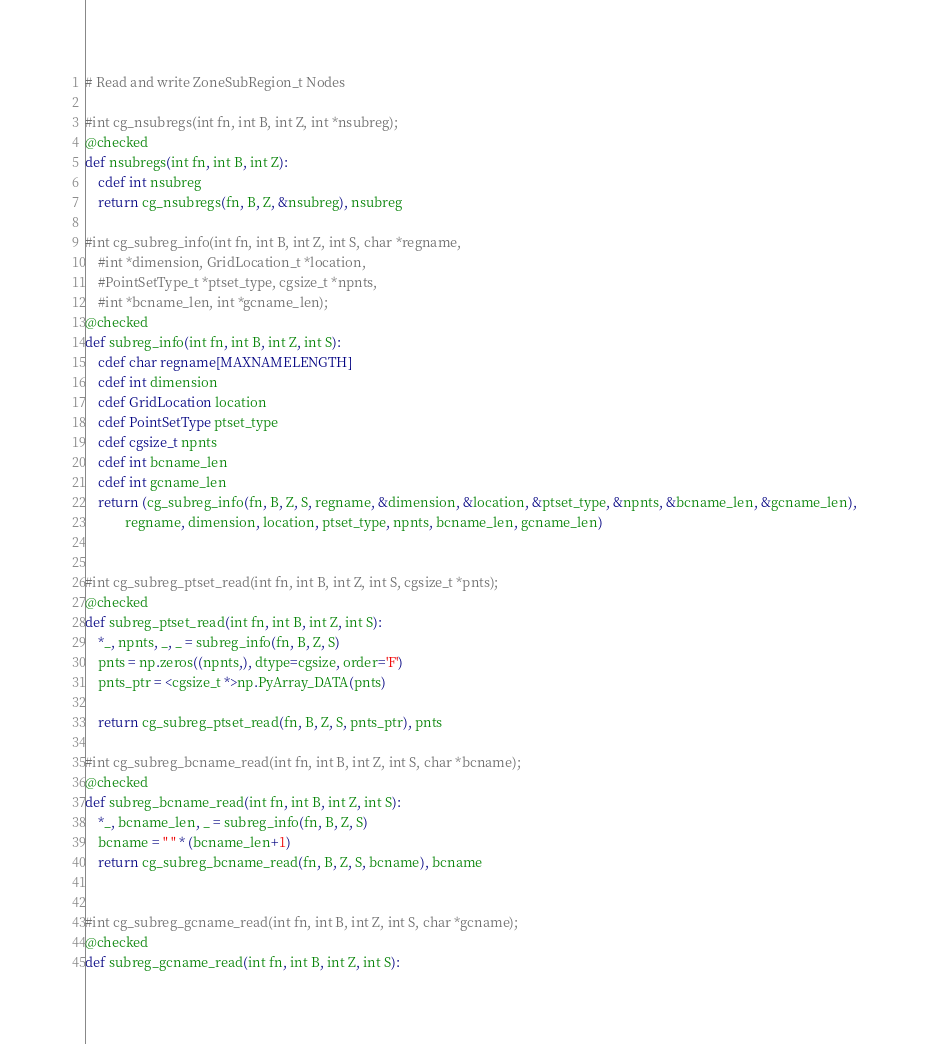<code> <loc_0><loc_0><loc_500><loc_500><_Cython_># Read and write ZoneSubRegion_t Nodes

#int cg_nsubregs(int fn, int B, int Z, int *nsubreg);
@checked
def nsubregs(int fn, int B, int Z):
    cdef int nsubreg
    return cg_nsubregs(fn, B, Z, &nsubreg), nsubreg

#int cg_subreg_info(int fn, int B, int Z, int S, char *regname,
    #int *dimension, GridLocation_t *location,
    #PointSetType_t *ptset_type, cgsize_t *npnts,
    #int *bcname_len, int *gcname_len);
@checked
def subreg_info(int fn, int B, int Z, int S):
    cdef char regname[MAXNAMELENGTH]
    cdef int dimension
    cdef GridLocation location
    cdef PointSetType ptset_type
    cdef cgsize_t npnts
    cdef int bcname_len
    cdef int gcname_len
    return (cg_subreg_info(fn, B, Z, S, regname, &dimension, &location, &ptset_type, &npnts, &bcname_len, &gcname_len),
            regname, dimension, location, ptset_type, npnts, bcname_len, gcname_len)


#int cg_subreg_ptset_read(int fn, int B, int Z, int S, cgsize_t *pnts);
@checked
def subreg_ptset_read(int fn, int B, int Z, int S):
    *_, npnts, _, _ = subreg_info(fn, B, Z, S)
    pnts = np.zeros((npnts,), dtype=cgsize, order='F')
    pnts_ptr = <cgsize_t *>np.PyArray_DATA(pnts)

    return cg_subreg_ptset_read(fn, B, Z, S, pnts_ptr), pnts

#int cg_subreg_bcname_read(int fn, int B, int Z, int S, char *bcname);
@checked
def subreg_bcname_read(int fn, int B, int Z, int S):
    *_, bcname_len, _ = subreg_info(fn, B, Z, S)
    bcname = " " * (bcname_len+1)
    return cg_subreg_bcname_read(fn, B, Z, S, bcname), bcname


#int cg_subreg_gcname_read(int fn, int B, int Z, int S, char *gcname);
@checked
def subreg_gcname_read(int fn, int B, int Z, int S):</code> 